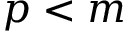<formula> <loc_0><loc_0><loc_500><loc_500>p < m</formula> 